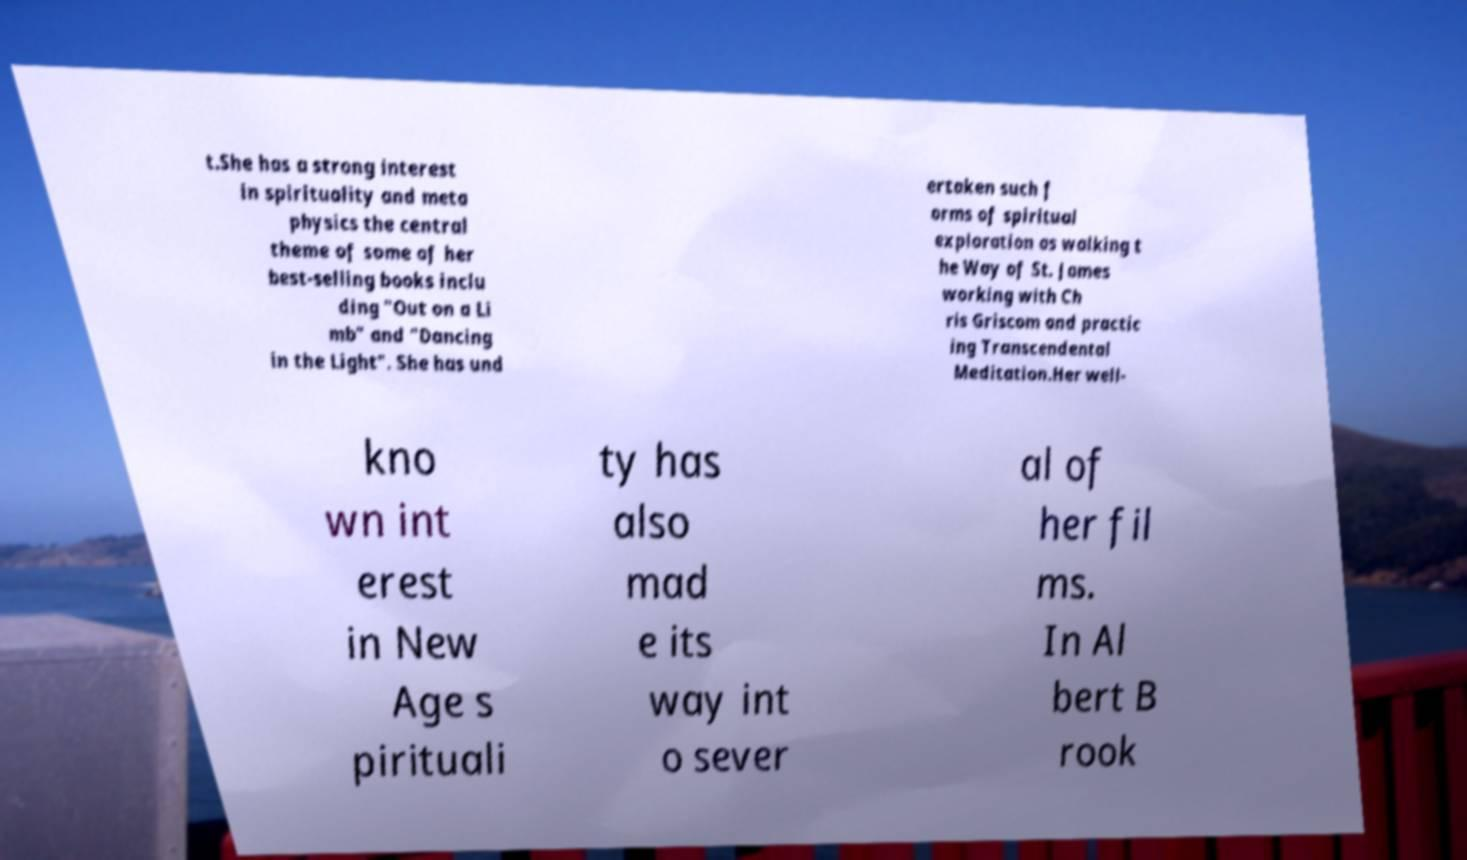There's text embedded in this image that I need extracted. Can you transcribe it verbatim? t.She has a strong interest in spirituality and meta physics the central theme of some of her best-selling books inclu ding "Out on a Li mb" and "Dancing in the Light". She has und ertaken such f orms of spiritual exploration as walking t he Way of St. James working with Ch ris Griscom and practic ing Transcendental Meditation.Her well- kno wn int erest in New Age s pirituali ty has also mad e its way int o sever al of her fil ms. In Al bert B rook 